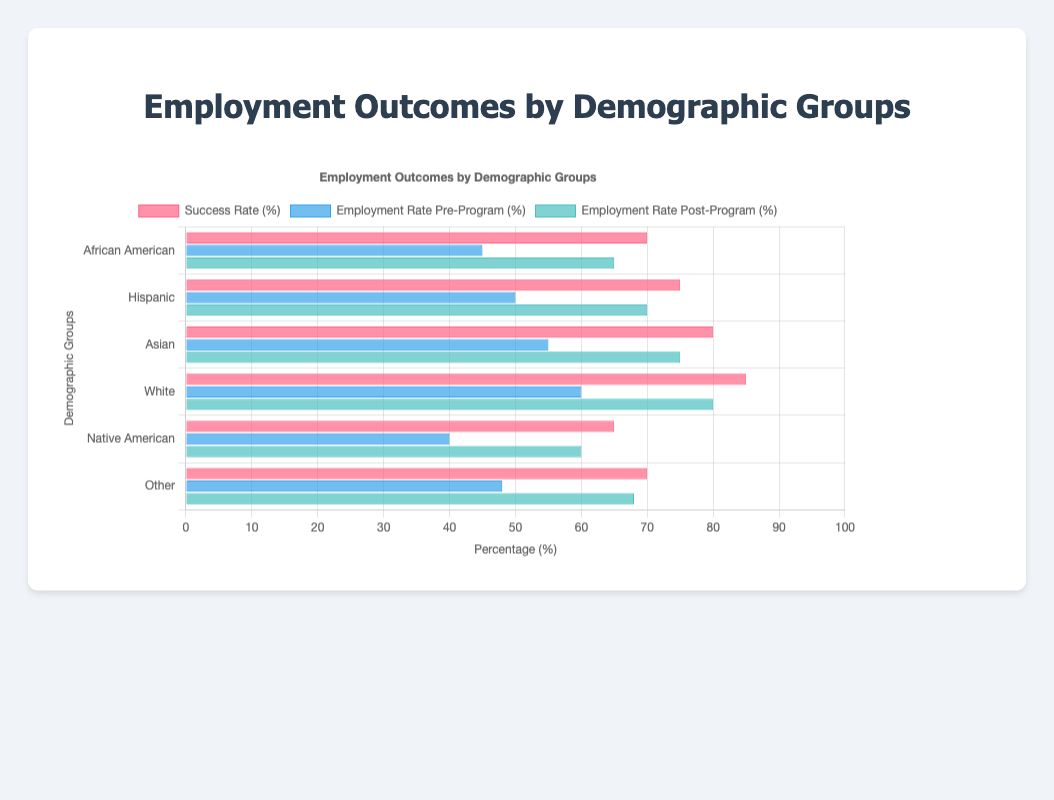What is the success rate of the demographic group with the highest pre-program employment rate? The demographic group with the highest pre-program employment rate is "White" at 60%. According to the chart, the success rate for this group is 85%.
Answer: 85% Which demographic group saw the largest increase in employment rate after completing the program? To determine the largest increase, we calculate the difference between pre-program and post-program employment rates for each group. African American: 20%, Hispanic: 20%, Asian: 20%, White: 20%, Native American: 20%, Other: 20%. Since all groups have the same increase of 20%, any group can be mentioned.
Answer: All groups saw the same increase of 20% Which group's post-program employment rate is closest to the average post-program employment rate across all groups? Average post-program employment rate = (65% + 70% + 75% + 80% + 60% + 68%) / 6 = 69.67%. The group closest to this value is "Hispanic" with 70%.
Answer: Hispanic What is the difference between the highest and lowest success rates among the demographic groups? The highest success rate is 85% (White), and the lowest is 65% (Native American). The difference is 85% - 65% = 20%.
Answer: 20% Which demographic group has the smallest difference between its pre-program and post-program employment rates? The calculation for each group is as follows: African American: 20%, Hispanic: 20%, Asian: 20%, White: 20%, Native American: 20%, Other: 20%. All groups have the same difference of 20%.
Answer: All groups have the same difference of 20% Compare the pre-program employment rates of "Asian" and "Native American" groups. Which one is higher and by how much? The pre-program employment rate for the "Asian" group is 55%, and for the "Native American" group, it is 40%. The difference is 55% - 40% = 15%.
Answer: Asian by 15% 